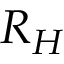Convert formula to latex. <formula><loc_0><loc_0><loc_500><loc_500>R _ { H }</formula> 